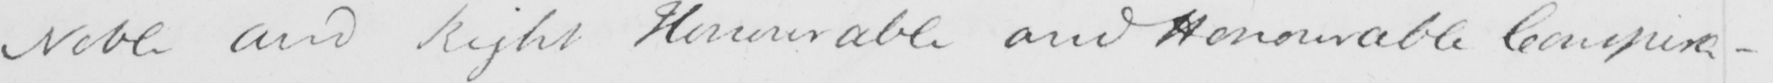Can you tell me what this handwritten text says? Noble and Right Honourable and Honourable Conspira- 